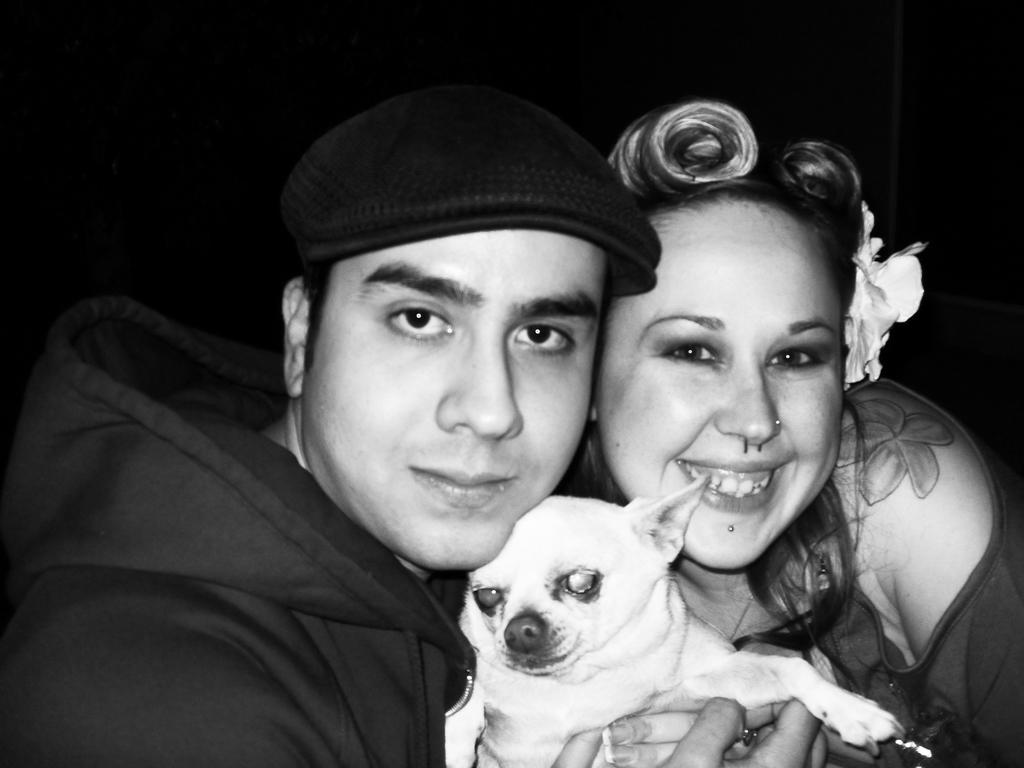What is the color scheme of the image? The image is black and white. Can you describe the people in the image? There is a man and a woman in the image. The man is wearing a cap and a jacket, while the woman is holding a puppy and has a flower on her head. What is the man wearing on his head? The man is wearing a cap. What is the woman holding in the image? The woman is holding a puppy. What is the cause of the volcano's eruption in the image? There is no volcano present in the image. How does the man's anger affect the woman in the image? There is no indication of anger or any negative emotions in the image. 